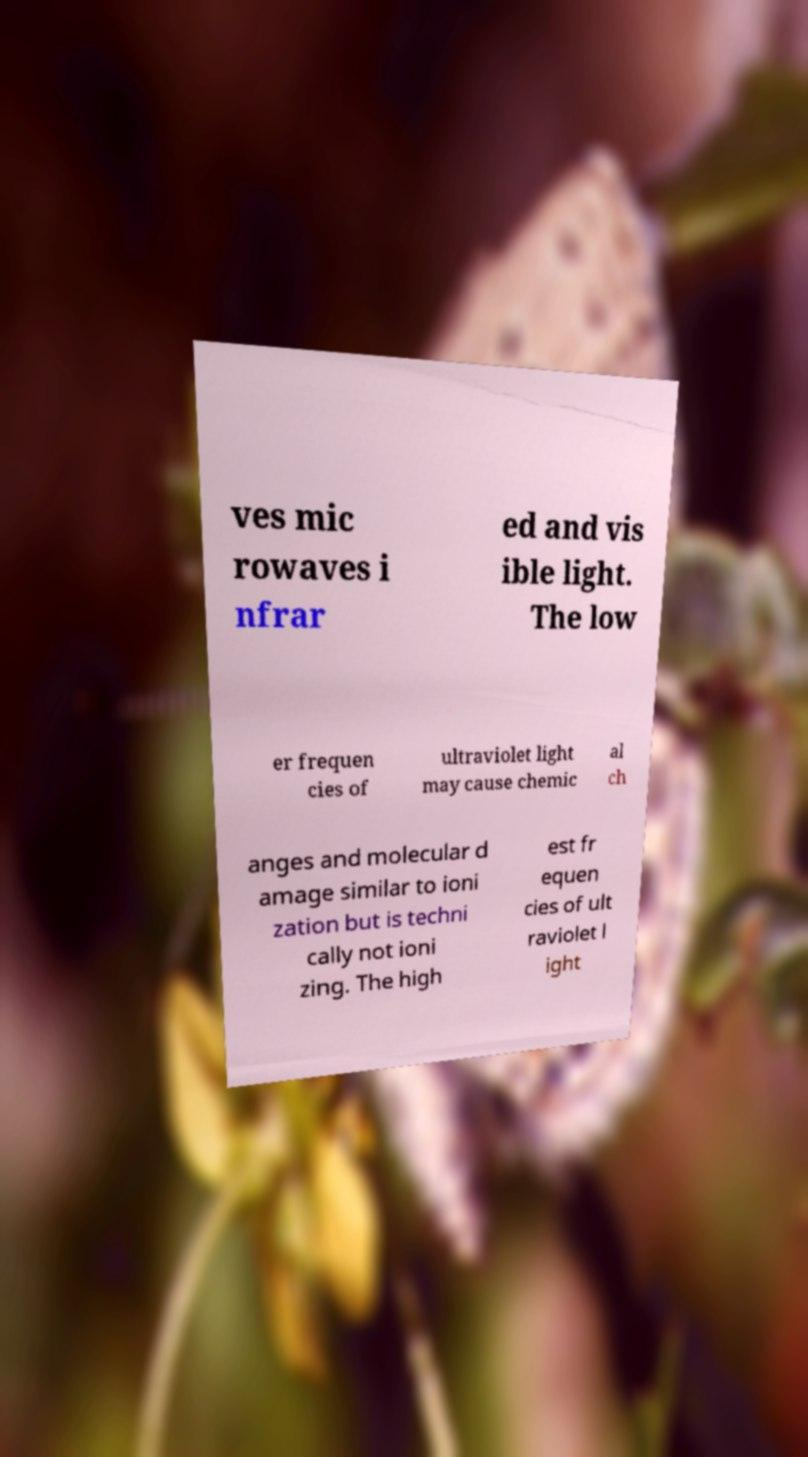Can you accurately transcribe the text from the provided image for me? ves mic rowaves i nfrar ed and vis ible light. The low er frequen cies of ultraviolet light may cause chemic al ch anges and molecular d amage similar to ioni zation but is techni cally not ioni zing. The high est fr equen cies of ult raviolet l ight 